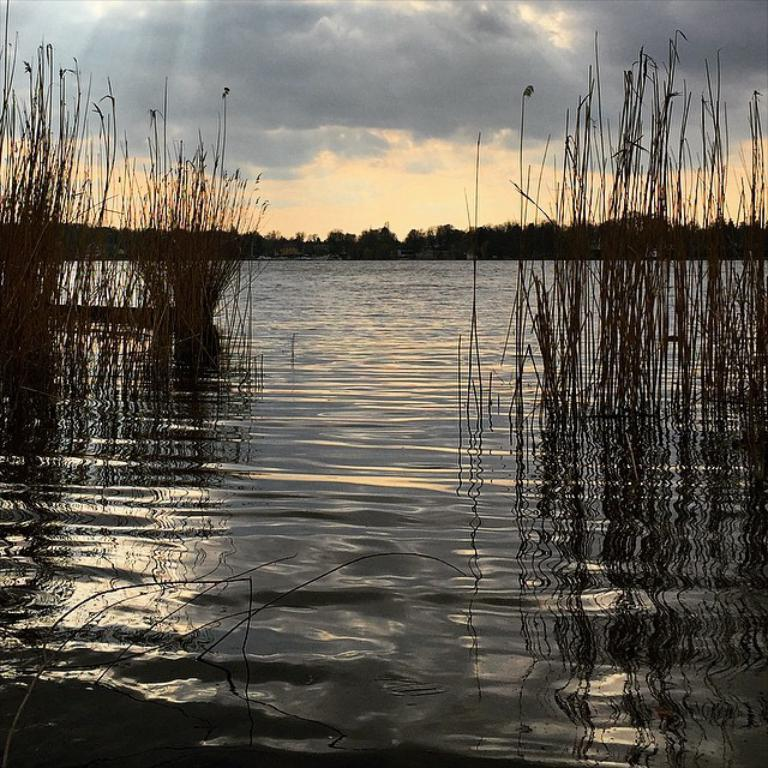What type of vegetation can be seen in the image? There is grass and trees visible in the image. What natural element is also present in the image? There is water visible in the image. What is visible in the background of the image? The sky is visible in the image. What can be observed in the sky? Clouds are present in the sky. How many women are paying attention to the hall in the image? There are no women or halls present in the image. 